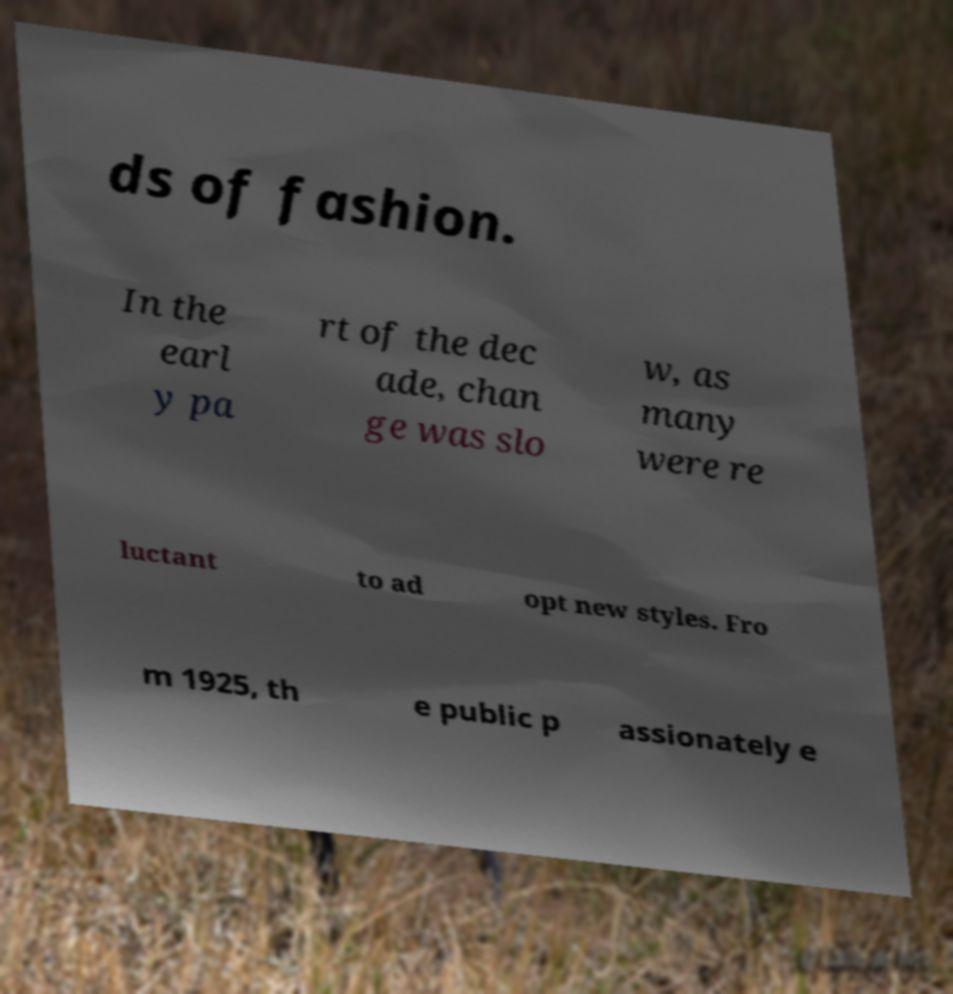Could you assist in decoding the text presented in this image and type it out clearly? ds of fashion. In the earl y pa rt of the dec ade, chan ge was slo w, as many were re luctant to ad opt new styles. Fro m 1925, th e public p assionately e 